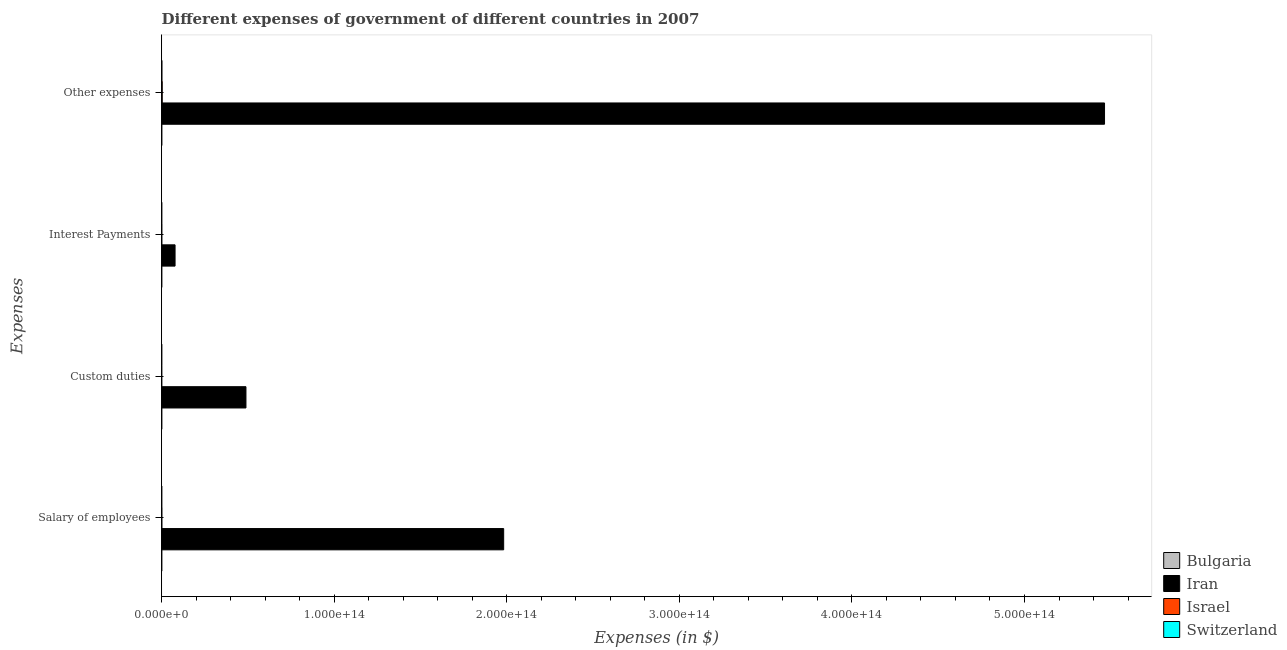How many different coloured bars are there?
Provide a succinct answer. 4. How many groups of bars are there?
Your answer should be compact. 4. How many bars are there on the 3rd tick from the top?
Ensure brevity in your answer.  4. What is the label of the 2nd group of bars from the top?
Provide a succinct answer. Interest Payments. What is the amount spent on custom duties in Switzerland?
Provide a succinct answer. 9.61e+08. Across all countries, what is the maximum amount spent on interest payments?
Offer a very short reply. 7.74e+12. Across all countries, what is the minimum amount spent on other expenses?
Ensure brevity in your answer.  1.81e+1. In which country was the amount spent on salary of employees maximum?
Make the answer very short. Iran. What is the total amount spent on other expenses in the graph?
Keep it short and to the point. 5.47e+14. What is the difference between the amount spent on other expenses in Switzerland and that in Israel?
Provide a succinct answer. -1.99e+11. What is the difference between the amount spent on other expenses in Israel and the amount spent on interest payments in Switzerland?
Your answer should be very brief. 2.88e+11. What is the average amount spent on salary of employees per country?
Offer a terse response. 4.96e+13. What is the difference between the amount spent on custom duties and amount spent on other expenses in Israel?
Provide a short and direct response. -2.90e+11. In how many countries, is the amount spent on salary of employees greater than 300000000000000 $?
Offer a terse response. 0. What is the ratio of the amount spent on custom duties in Iran to that in Switzerland?
Keep it short and to the point. 5.08e+04. Is the difference between the amount spent on interest payments in Bulgaria and Israel greater than the difference between the amount spent on other expenses in Bulgaria and Israel?
Your answer should be very brief. Yes. What is the difference between the highest and the second highest amount spent on interest payments?
Your answer should be compact. 7.70e+12. What is the difference between the highest and the lowest amount spent on salary of employees?
Ensure brevity in your answer.  1.98e+14. In how many countries, is the amount spent on other expenses greater than the average amount spent on other expenses taken over all countries?
Give a very brief answer. 1. Is it the case that in every country, the sum of the amount spent on custom duties and amount spent on interest payments is greater than the sum of amount spent on salary of employees and amount spent on other expenses?
Ensure brevity in your answer.  No. What does the 2nd bar from the bottom in Interest Payments represents?
Your answer should be very brief. Iran. How many bars are there?
Offer a terse response. 16. Are all the bars in the graph horizontal?
Your answer should be compact. Yes. How many countries are there in the graph?
Offer a very short reply. 4. What is the difference between two consecutive major ticks on the X-axis?
Keep it short and to the point. 1.00e+14. Are the values on the major ticks of X-axis written in scientific E-notation?
Make the answer very short. Yes. Does the graph contain any zero values?
Provide a succinct answer. No. Does the graph contain grids?
Provide a succinct answer. No. How are the legend labels stacked?
Provide a short and direct response. Vertical. What is the title of the graph?
Your answer should be compact. Different expenses of government of different countries in 2007. What is the label or title of the X-axis?
Your response must be concise. Expenses (in $). What is the label or title of the Y-axis?
Offer a very short reply. Expenses. What is the Expenses (in $) in Bulgaria in Salary of employees?
Ensure brevity in your answer.  3.29e+09. What is the Expenses (in $) of Iran in Salary of employees?
Ensure brevity in your answer.  1.98e+14. What is the Expenses (in $) in Israel in Salary of employees?
Provide a short and direct response. 6.83e+1. What is the Expenses (in $) of Switzerland in Salary of employees?
Offer a very short reply. 5.73e+09. What is the Expenses (in $) of Bulgaria in Custom duties?
Offer a very short reply. 1.93e+08. What is the Expenses (in $) of Iran in Custom duties?
Offer a very short reply. 4.88e+13. What is the Expenses (in $) in Israel in Custom duties?
Offer a terse response. 2.22e+09. What is the Expenses (in $) in Switzerland in Custom duties?
Give a very brief answer. 9.61e+08. What is the Expenses (in $) of Bulgaria in Interest Payments?
Your answer should be very brief. 6.19e+08. What is the Expenses (in $) in Iran in Interest Payments?
Keep it short and to the point. 7.74e+12. What is the Expenses (in $) of Israel in Interest Payments?
Make the answer very short. 3.85e+1. What is the Expenses (in $) of Switzerland in Interest Payments?
Offer a very short reply. 4.00e+09. What is the Expenses (in $) of Bulgaria in Other expenses?
Offer a terse response. 1.81e+1. What is the Expenses (in $) of Iran in Other expenses?
Your answer should be compact. 5.46e+14. What is the Expenses (in $) of Israel in Other expenses?
Your response must be concise. 2.92e+11. What is the Expenses (in $) of Switzerland in Other expenses?
Keep it short and to the point. 9.30e+1. Across all Expenses, what is the maximum Expenses (in $) in Bulgaria?
Provide a succinct answer. 1.81e+1. Across all Expenses, what is the maximum Expenses (in $) of Iran?
Offer a terse response. 5.46e+14. Across all Expenses, what is the maximum Expenses (in $) of Israel?
Your response must be concise. 2.92e+11. Across all Expenses, what is the maximum Expenses (in $) of Switzerland?
Offer a terse response. 9.30e+1. Across all Expenses, what is the minimum Expenses (in $) in Bulgaria?
Provide a succinct answer. 1.93e+08. Across all Expenses, what is the minimum Expenses (in $) in Iran?
Your response must be concise. 7.74e+12. Across all Expenses, what is the minimum Expenses (in $) in Israel?
Provide a short and direct response. 2.22e+09. Across all Expenses, what is the minimum Expenses (in $) in Switzerland?
Offer a terse response. 9.61e+08. What is the total Expenses (in $) in Bulgaria in the graph?
Provide a succinct answer. 2.22e+1. What is the total Expenses (in $) in Iran in the graph?
Offer a very short reply. 8.01e+14. What is the total Expenses (in $) of Israel in the graph?
Offer a terse response. 4.01e+11. What is the total Expenses (in $) of Switzerland in the graph?
Offer a terse response. 1.04e+11. What is the difference between the Expenses (in $) of Bulgaria in Salary of employees and that in Custom duties?
Keep it short and to the point. 3.10e+09. What is the difference between the Expenses (in $) in Iran in Salary of employees and that in Custom duties?
Provide a succinct answer. 1.49e+14. What is the difference between the Expenses (in $) in Israel in Salary of employees and that in Custom duties?
Your answer should be very brief. 6.61e+1. What is the difference between the Expenses (in $) in Switzerland in Salary of employees and that in Custom duties?
Provide a short and direct response. 4.77e+09. What is the difference between the Expenses (in $) in Bulgaria in Salary of employees and that in Interest Payments?
Provide a short and direct response. 2.67e+09. What is the difference between the Expenses (in $) in Iran in Salary of employees and that in Interest Payments?
Provide a short and direct response. 1.90e+14. What is the difference between the Expenses (in $) of Israel in Salary of employees and that in Interest Payments?
Your answer should be compact. 2.98e+1. What is the difference between the Expenses (in $) in Switzerland in Salary of employees and that in Interest Payments?
Give a very brief answer. 1.74e+09. What is the difference between the Expenses (in $) of Bulgaria in Salary of employees and that in Other expenses?
Provide a short and direct response. -1.48e+1. What is the difference between the Expenses (in $) in Iran in Salary of employees and that in Other expenses?
Make the answer very short. -3.48e+14. What is the difference between the Expenses (in $) of Israel in Salary of employees and that in Other expenses?
Your response must be concise. -2.24e+11. What is the difference between the Expenses (in $) of Switzerland in Salary of employees and that in Other expenses?
Offer a terse response. -8.73e+1. What is the difference between the Expenses (in $) in Bulgaria in Custom duties and that in Interest Payments?
Ensure brevity in your answer.  -4.26e+08. What is the difference between the Expenses (in $) in Iran in Custom duties and that in Interest Payments?
Your answer should be very brief. 4.11e+13. What is the difference between the Expenses (in $) of Israel in Custom duties and that in Interest Payments?
Offer a terse response. -3.63e+1. What is the difference between the Expenses (in $) in Switzerland in Custom duties and that in Interest Payments?
Your answer should be compact. -3.03e+09. What is the difference between the Expenses (in $) in Bulgaria in Custom duties and that in Other expenses?
Make the answer very short. -1.79e+1. What is the difference between the Expenses (in $) of Iran in Custom duties and that in Other expenses?
Provide a short and direct response. -4.98e+14. What is the difference between the Expenses (in $) in Israel in Custom duties and that in Other expenses?
Your answer should be compact. -2.90e+11. What is the difference between the Expenses (in $) in Switzerland in Custom duties and that in Other expenses?
Provide a short and direct response. -9.20e+1. What is the difference between the Expenses (in $) of Bulgaria in Interest Payments and that in Other expenses?
Give a very brief answer. -1.75e+1. What is the difference between the Expenses (in $) of Iran in Interest Payments and that in Other expenses?
Offer a very short reply. -5.39e+14. What is the difference between the Expenses (in $) of Israel in Interest Payments and that in Other expenses?
Keep it short and to the point. -2.54e+11. What is the difference between the Expenses (in $) in Switzerland in Interest Payments and that in Other expenses?
Your response must be concise. -8.90e+1. What is the difference between the Expenses (in $) in Bulgaria in Salary of employees and the Expenses (in $) in Iran in Custom duties?
Ensure brevity in your answer.  -4.88e+13. What is the difference between the Expenses (in $) of Bulgaria in Salary of employees and the Expenses (in $) of Israel in Custom duties?
Provide a short and direct response. 1.08e+09. What is the difference between the Expenses (in $) in Bulgaria in Salary of employees and the Expenses (in $) in Switzerland in Custom duties?
Keep it short and to the point. 2.33e+09. What is the difference between the Expenses (in $) in Iran in Salary of employees and the Expenses (in $) in Israel in Custom duties?
Your answer should be compact. 1.98e+14. What is the difference between the Expenses (in $) of Iran in Salary of employees and the Expenses (in $) of Switzerland in Custom duties?
Offer a terse response. 1.98e+14. What is the difference between the Expenses (in $) of Israel in Salary of employees and the Expenses (in $) of Switzerland in Custom duties?
Your answer should be compact. 6.74e+1. What is the difference between the Expenses (in $) of Bulgaria in Salary of employees and the Expenses (in $) of Iran in Interest Payments?
Provide a short and direct response. -7.73e+12. What is the difference between the Expenses (in $) in Bulgaria in Salary of employees and the Expenses (in $) in Israel in Interest Payments?
Provide a short and direct response. -3.52e+1. What is the difference between the Expenses (in $) of Bulgaria in Salary of employees and the Expenses (in $) of Switzerland in Interest Payments?
Provide a short and direct response. -7.02e+08. What is the difference between the Expenses (in $) in Iran in Salary of employees and the Expenses (in $) in Israel in Interest Payments?
Give a very brief answer. 1.98e+14. What is the difference between the Expenses (in $) of Iran in Salary of employees and the Expenses (in $) of Switzerland in Interest Payments?
Your answer should be compact. 1.98e+14. What is the difference between the Expenses (in $) of Israel in Salary of employees and the Expenses (in $) of Switzerland in Interest Payments?
Keep it short and to the point. 6.43e+1. What is the difference between the Expenses (in $) in Bulgaria in Salary of employees and the Expenses (in $) in Iran in Other expenses?
Provide a short and direct response. -5.46e+14. What is the difference between the Expenses (in $) of Bulgaria in Salary of employees and the Expenses (in $) of Israel in Other expenses?
Keep it short and to the point. -2.89e+11. What is the difference between the Expenses (in $) of Bulgaria in Salary of employees and the Expenses (in $) of Switzerland in Other expenses?
Provide a succinct answer. -8.97e+1. What is the difference between the Expenses (in $) in Iran in Salary of employees and the Expenses (in $) in Israel in Other expenses?
Your answer should be compact. 1.98e+14. What is the difference between the Expenses (in $) of Iran in Salary of employees and the Expenses (in $) of Switzerland in Other expenses?
Make the answer very short. 1.98e+14. What is the difference between the Expenses (in $) in Israel in Salary of employees and the Expenses (in $) in Switzerland in Other expenses?
Keep it short and to the point. -2.47e+1. What is the difference between the Expenses (in $) of Bulgaria in Custom duties and the Expenses (in $) of Iran in Interest Payments?
Your response must be concise. -7.74e+12. What is the difference between the Expenses (in $) of Bulgaria in Custom duties and the Expenses (in $) of Israel in Interest Payments?
Ensure brevity in your answer.  -3.83e+1. What is the difference between the Expenses (in $) of Bulgaria in Custom duties and the Expenses (in $) of Switzerland in Interest Payments?
Your answer should be compact. -3.80e+09. What is the difference between the Expenses (in $) in Iran in Custom duties and the Expenses (in $) in Israel in Interest Payments?
Your answer should be very brief. 4.88e+13. What is the difference between the Expenses (in $) in Iran in Custom duties and the Expenses (in $) in Switzerland in Interest Payments?
Your response must be concise. 4.88e+13. What is the difference between the Expenses (in $) in Israel in Custom duties and the Expenses (in $) in Switzerland in Interest Payments?
Make the answer very short. -1.78e+09. What is the difference between the Expenses (in $) of Bulgaria in Custom duties and the Expenses (in $) of Iran in Other expenses?
Your response must be concise. -5.46e+14. What is the difference between the Expenses (in $) in Bulgaria in Custom duties and the Expenses (in $) in Israel in Other expenses?
Provide a short and direct response. -2.92e+11. What is the difference between the Expenses (in $) of Bulgaria in Custom duties and the Expenses (in $) of Switzerland in Other expenses?
Your answer should be compact. -9.28e+1. What is the difference between the Expenses (in $) in Iran in Custom duties and the Expenses (in $) in Israel in Other expenses?
Provide a short and direct response. 4.85e+13. What is the difference between the Expenses (in $) of Iran in Custom duties and the Expenses (in $) of Switzerland in Other expenses?
Your answer should be very brief. 4.87e+13. What is the difference between the Expenses (in $) in Israel in Custom duties and the Expenses (in $) in Switzerland in Other expenses?
Ensure brevity in your answer.  -9.08e+1. What is the difference between the Expenses (in $) in Bulgaria in Interest Payments and the Expenses (in $) in Iran in Other expenses?
Provide a succinct answer. -5.46e+14. What is the difference between the Expenses (in $) of Bulgaria in Interest Payments and the Expenses (in $) of Israel in Other expenses?
Provide a short and direct response. -2.91e+11. What is the difference between the Expenses (in $) of Bulgaria in Interest Payments and the Expenses (in $) of Switzerland in Other expenses?
Ensure brevity in your answer.  -9.24e+1. What is the difference between the Expenses (in $) in Iran in Interest Payments and the Expenses (in $) in Israel in Other expenses?
Your answer should be compact. 7.44e+12. What is the difference between the Expenses (in $) in Iran in Interest Payments and the Expenses (in $) in Switzerland in Other expenses?
Offer a terse response. 7.64e+12. What is the difference between the Expenses (in $) of Israel in Interest Payments and the Expenses (in $) of Switzerland in Other expenses?
Your answer should be compact. -5.45e+1. What is the average Expenses (in $) in Bulgaria per Expenses?
Ensure brevity in your answer.  5.55e+09. What is the average Expenses (in $) in Iran per Expenses?
Offer a terse response. 2.00e+14. What is the average Expenses (in $) of Israel per Expenses?
Make the answer very short. 1.00e+11. What is the average Expenses (in $) of Switzerland per Expenses?
Your answer should be compact. 2.59e+1. What is the difference between the Expenses (in $) in Bulgaria and Expenses (in $) in Iran in Salary of employees?
Your response must be concise. -1.98e+14. What is the difference between the Expenses (in $) in Bulgaria and Expenses (in $) in Israel in Salary of employees?
Give a very brief answer. -6.50e+1. What is the difference between the Expenses (in $) of Bulgaria and Expenses (in $) of Switzerland in Salary of employees?
Provide a succinct answer. -2.44e+09. What is the difference between the Expenses (in $) of Iran and Expenses (in $) of Israel in Salary of employees?
Your answer should be very brief. 1.98e+14. What is the difference between the Expenses (in $) of Iran and Expenses (in $) of Switzerland in Salary of employees?
Provide a succinct answer. 1.98e+14. What is the difference between the Expenses (in $) in Israel and Expenses (in $) in Switzerland in Salary of employees?
Make the answer very short. 6.26e+1. What is the difference between the Expenses (in $) of Bulgaria and Expenses (in $) of Iran in Custom duties?
Offer a very short reply. -4.88e+13. What is the difference between the Expenses (in $) in Bulgaria and Expenses (in $) in Israel in Custom duties?
Provide a succinct answer. -2.02e+09. What is the difference between the Expenses (in $) of Bulgaria and Expenses (in $) of Switzerland in Custom duties?
Ensure brevity in your answer.  -7.67e+08. What is the difference between the Expenses (in $) in Iran and Expenses (in $) in Israel in Custom duties?
Offer a very short reply. 4.88e+13. What is the difference between the Expenses (in $) of Iran and Expenses (in $) of Switzerland in Custom duties?
Your answer should be compact. 4.88e+13. What is the difference between the Expenses (in $) of Israel and Expenses (in $) of Switzerland in Custom duties?
Offer a very short reply. 1.25e+09. What is the difference between the Expenses (in $) of Bulgaria and Expenses (in $) of Iran in Interest Payments?
Ensure brevity in your answer.  -7.74e+12. What is the difference between the Expenses (in $) in Bulgaria and Expenses (in $) in Israel in Interest Payments?
Your response must be concise. -3.79e+1. What is the difference between the Expenses (in $) in Bulgaria and Expenses (in $) in Switzerland in Interest Payments?
Your response must be concise. -3.38e+09. What is the difference between the Expenses (in $) in Iran and Expenses (in $) in Israel in Interest Payments?
Keep it short and to the point. 7.70e+12. What is the difference between the Expenses (in $) of Iran and Expenses (in $) of Switzerland in Interest Payments?
Provide a succinct answer. 7.73e+12. What is the difference between the Expenses (in $) of Israel and Expenses (in $) of Switzerland in Interest Payments?
Keep it short and to the point. 3.45e+1. What is the difference between the Expenses (in $) of Bulgaria and Expenses (in $) of Iran in Other expenses?
Ensure brevity in your answer.  -5.46e+14. What is the difference between the Expenses (in $) in Bulgaria and Expenses (in $) in Israel in Other expenses?
Your response must be concise. -2.74e+11. What is the difference between the Expenses (in $) in Bulgaria and Expenses (in $) in Switzerland in Other expenses?
Your answer should be very brief. -7.49e+1. What is the difference between the Expenses (in $) in Iran and Expenses (in $) in Israel in Other expenses?
Provide a succinct answer. 5.46e+14. What is the difference between the Expenses (in $) of Iran and Expenses (in $) of Switzerland in Other expenses?
Offer a terse response. 5.46e+14. What is the difference between the Expenses (in $) in Israel and Expenses (in $) in Switzerland in Other expenses?
Offer a terse response. 1.99e+11. What is the ratio of the Expenses (in $) in Bulgaria in Salary of employees to that in Custom duties?
Your answer should be very brief. 17.06. What is the ratio of the Expenses (in $) in Iran in Salary of employees to that in Custom duties?
Give a very brief answer. 4.06. What is the ratio of the Expenses (in $) in Israel in Salary of employees to that in Custom duties?
Give a very brief answer. 30.84. What is the ratio of the Expenses (in $) of Switzerland in Salary of employees to that in Custom duties?
Make the answer very short. 5.97. What is the ratio of the Expenses (in $) in Bulgaria in Salary of employees to that in Interest Payments?
Provide a short and direct response. 5.32. What is the ratio of the Expenses (in $) in Iran in Salary of employees to that in Interest Payments?
Provide a short and direct response. 25.61. What is the ratio of the Expenses (in $) in Israel in Salary of employees to that in Interest Payments?
Offer a very short reply. 1.77. What is the ratio of the Expenses (in $) of Switzerland in Salary of employees to that in Interest Payments?
Make the answer very short. 1.44. What is the ratio of the Expenses (in $) in Bulgaria in Salary of employees to that in Other expenses?
Your answer should be compact. 0.18. What is the ratio of the Expenses (in $) in Iran in Salary of employees to that in Other expenses?
Offer a very short reply. 0.36. What is the ratio of the Expenses (in $) in Israel in Salary of employees to that in Other expenses?
Provide a short and direct response. 0.23. What is the ratio of the Expenses (in $) in Switzerland in Salary of employees to that in Other expenses?
Your answer should be very brief. 0.06. What is the ratio of the Expenses (in $) in Bulgaria in Custom duties to that in Interest Payments?
Offer a terse response. 0.31. What is the ratio of the Expenses (in $) of Iran in Custom duties to that in Interest Payments?
Ensure brevity in your answer.  6.31. What is the ratio of the Expenses (in $) of Israel in Custom duties to that in Interest Payments?
Your response must be concise. 0.06. What is the ratio of the Expenses (in $) of Switzerland in Custom duties to that in Interest Payments?
Provide a succinct answer. 0.24. What is the ratio of the Expenses (in $) in Bulgaria in Custom duties to that in Other expenses?
Keep it short and to the point. 0.01. What is the ratio of the Expenses (in $) of Iran in Custom duties to that in Other expenses?
Provide a short and direct response. 0.09. What is the ratio of the Expenses (in $) of Israel in Custom duties to that in Other expenses?
Your answer should be compact. 0.01. What is the ratio of the Expenses (in $) of Switzerland in Custom duties to that in Other expenses?
Provide a short and direct response. 0.01. What is the ratio of the Expenses (in $) of Bulgaria in Interest Payments to that in Other expenses?
Ensure brevity in your answer.  0.03. What is the ratio of the Expenses (in $) in Iran in Interest Payments to that in Other expenses?
Offer a very short reply. 0.01. What is the ratio of the Expenses (in $) in Israel in Interest Payments to that in Other expenses?
Offer a very short reply. 0.13. What is the ratio of the Expenses (in $) in Switzerland in Interest Payments to that in Other expenses?
Your answer should be compact. 0.04. What is the difference between the highest and the second highest Expenses (in $) in Bulgaria?
Offer a terse response. 1.48e+1. What is the difference between the highest and the second highest Expenses (in $) in Iran?
Your answer should be compact. 3.48e+14. What is the difference between the highest and the second highest Expenses (in $) of Israel?
Make the answer very short. 2.24e+11. What is the difference between the highest and the second highest Expenses (in $) in Switzerland?
Offer a very short reply. 8.73e+1. What is the difference between the highest and the lowest Expenses (in $) in Bulgaria?
Offer a terse response. 1.79e+1. What is the difference between the highest and the lowest Expenses (in $) of Iran?
Your answer should be compact. 5.39e+14. What is the difference between the highest and the lowest Expenses (in $) of Israel?
Provide a succinct answer. 2.90e+11. What is the difference between the highest and the lowest Expenses (in $) of Switzerland?
Offer a very short reply. 9.20e+1. 